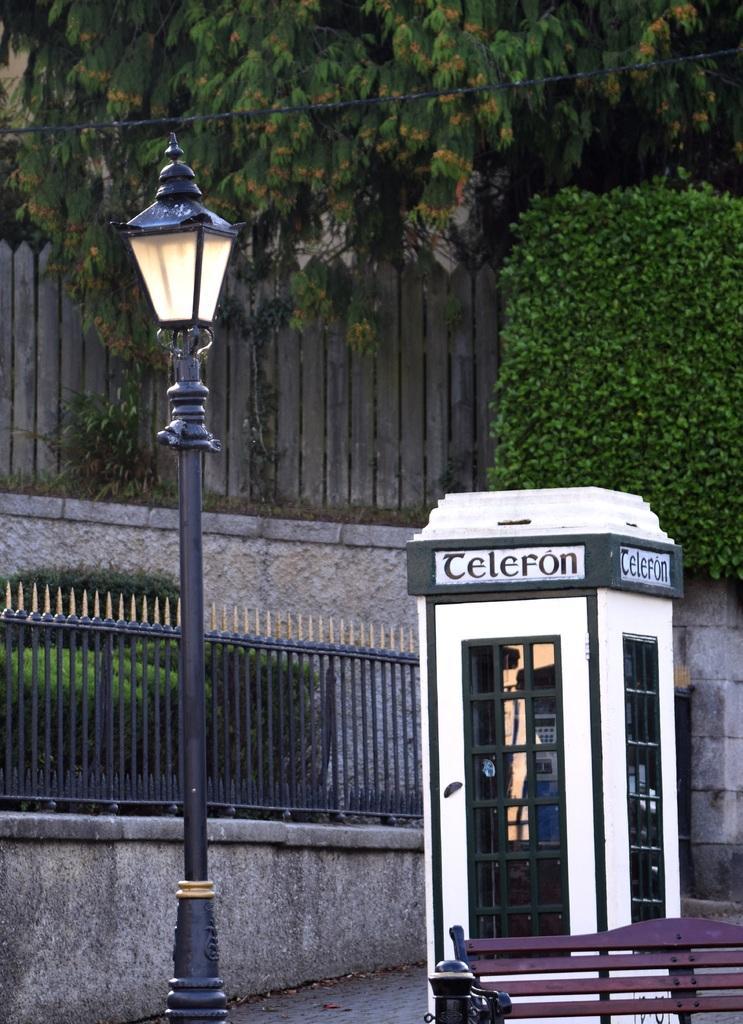Could you give a brief overview of what you see in this image? In this image on the left side there is one pole and light, and on the right side there is one booth, bench. And in the background there is a railing, wall and some trees. At the bottom there is a walkway. 